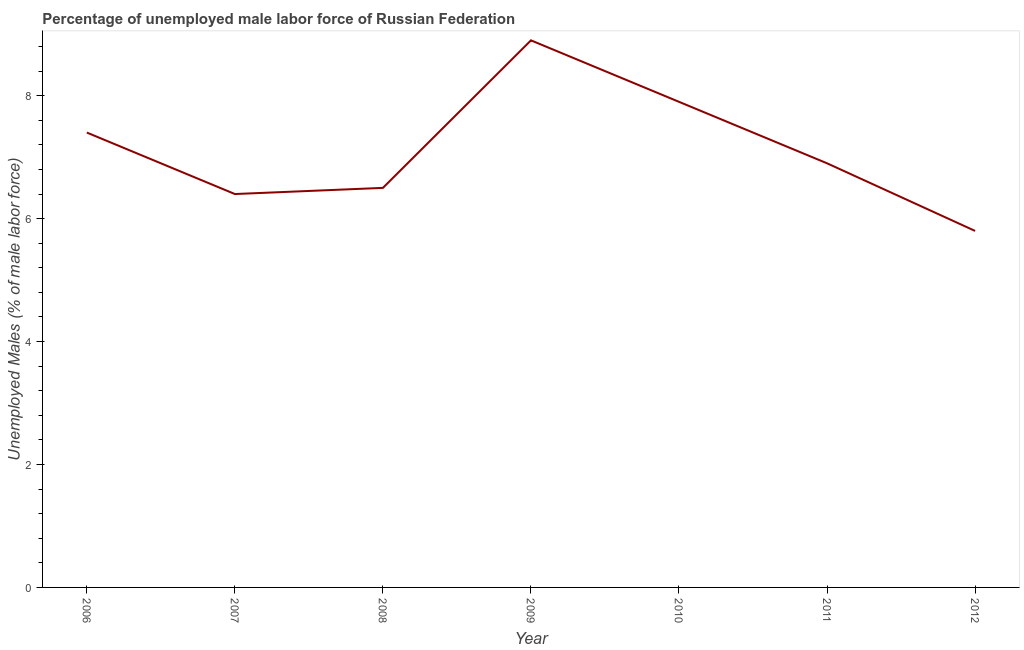What is the total unemployed male labour force in 2010?
Your answer should be compact. 7.9. Across all years, what is the maximum total unemployed male labour force?
Give a very brief answer. 8.9. Across all years, what is the minimum total unemployed male labour force?
Give a very brief answer. 5.8. In which year was the total unemployed male labour force maximum?
Ensure brevity in your answer.  2009. In which year was the total unemployed male labour force minimum?
Offer a terse response. 2012. What is the sum of the total unemployed male labour force?
Provide a succinct answer. 49.8. What is the difference between the total unemployed male labour force in 2007 and 2012?
Your answer should be very brief. 0.6. What is the average total unemployed male labour force per year?
Provide a succinct answer. 7.11. What is the median total unemployed male labour force?
Make the answer very short. 6.9. In how many years, is the total unemployed male labour force greater than 6.8 %?
Provide a succinct answer. 4. Do a majority of the years between 2010 and 2012 (inclusive) have total unemployed male labour force greater than 2.4 %?
Your answer should be very brief. Yes. What is the ratio of the total unemployed male labour force in 2007 to that in 2008?
Provide a succinct answer. 0.98. Is the total unemployed male labour force in 2008 less than that in 2010?
Your answer should be very brief. Yes. What is the difference between the highest and the second highest total unemployed male labour force?
Give a very brief answer. 1. Is the sum of the total unemployed male labour force in 2006 and 2011 greater than the maximum total unemployed male labour force across all years?
Ensure brevity in your answer.  Yes. What is the difference between the highest and the lowest total unemployed male labour force?
Your answer should be very brief. 3.1. How many lines are there?
Your answer should be very brief. 1. How many years are there in the graph?
Offer a terse response. 7. What is the difference between two consecutive major ticks on the Y-axis?
Offer a terse response. 2. Does the graph contain grids?
Make the answer very short. No. What is the title of the graph?
Give a very brief answer. Percentage of unemployed male labor force of Russian Federation. What is the label or title of the X-axis?
Keep it short and to the point. Year. What is the label or title of the Y-axis?
Offer a terse response. Unemployed Males (% of male labor force). What is the Unemployed Males (% of male labor force) of 2006?
Give a very brief answer. 7.4. What is the Unemployed Males (% of male labor force) of 2007?
Offer a very short reply. 6.4. What is the Unemployed Males (% of male labor force) of 2009?
Make the answer very short. 8.9. What is the Unemployed Males (% of male labor force) in 2010?
Keep it short and to the point. 7.9. What is the Unemployed Males (% of male labor force) of 2011?
Offer a terse response. 6.9. What is the Unemployed Males (% of male labor force) in 2012?
Make the answer very short. 5.8. What is the difference between the Unemployed Males (% of male labor force) in 2006 and 2008?
Your response must be concise. 0.9. What is the difference between the Unemployed Males (% of male labor force) in 2007 and 2008?
Your answer should be very brief. -0.1. What is the difference between the Unemployed Males (% of male labor force) in 2007 and 2009?
Ensure brevity in your answer.  -2.5. What is the difference between the Unemployed Males (% of male labor force) in 2007 and 2011?
Offer a terse response. -0.5. What is the difference between the Unemployed Males (% of male labor force) in 2008 and 2009?
Provide a short and direct response. -2.4. What is the difference between the Unemployed Males (% of male labor force) in 2008 and 2010?
Provide a succinct answer. -1.4. What is the difference between the Unemployed Males (% of male labor force) in 2008 and 2011?
Provide a succinct answer. -0.4. What is the difference between the Unemployed Males (% of male labor force) in 2008 and 2012?
Your answer should be compact. 0.7. What is the ratio of the Unemployed Males (% of male labor force) in 2006 to that in 2007?
Make the answer very short. 1.16. What is the ratio of the Unemployed Males (% of male labor force) in 2006 to that in 2008?
Your answer should be very brief. 1.14. What is the ratio of the Unemployed Males (% of male labor force) in 2006 to that in 2009?
Offer a very short reply. 0.83. What is the ratio of the Unemployed Males (% of male labor force) in 2006 to that in 2010?
Give a very brief answer. 0.94. What is the ratio of the Unemployed Males (% of male labor force) in 2006 to that in 2011?
Provide a short and direct response. 1.07. What is the ratio of the Unemployed Males (% of male labor force) in 2006 to that in 2012?
Offer a terse response. 1.28. What is the ratio of the Unemployed Males (% of male labor force) in 2007 to that in 2008?
Your answer should be compact. 0.98. What is the ratio of the Unemployed Males (% of male labor force) in 2007 to that in 2009?
Offer a terse response. 0.72. What is the ratio of the Unemployed Males (% of male labor force) in 2007 to that in 2010?
Keep it short and to the point. 0.81. What is the ratio of the Unemployed Males (% of male labor force) in 2007 to that in 2011?
Provide a succinct answer. 0.93. What is the ratio of the Unemployed Males (% of male labor force) in 2007 to that in 2012?
Your answer should be very brief. 1.1. What is the ratio of the Unemployed Males (% of male labor force) in 2008 to that in 2009?
Your answer should be compact. 0.73. What is the ratio of the Unemployed Males (% of male labor force) in 2008 to that in 2010?
Your response must be concise. 0.82. What is the ratio of the Unemployed Males (% of male labor force) in 2008 to that in 2011?
Make the answer very short. 0.94. What is the ratio of the Unemployed Males (% of male labor force) in 2008 to that in 2012?
Make the answer very short. 1.12. What is the ratio of the Unemployed Males (% of male labor force) in 2009 to that in 2010?
Your answer should be compact. 1.13. What is the ratio of the Unemployed Males (% of male labor force) in 2009 to that in 2011?
Make the answer very short. 1.29. What is the ratio of the Unemployed Males (% of male labor force) in 2009 to that in 2012?
Your response must be concise. 1.53. What is the ratio of the Unemployed Males (% of male labor force) in 2010 to that in 2011?
Make the answer very short. 1.15. What is the ratio of the Unemployed Males (% of male labor force) in 2010 to that in 2012?
Offer a very short reply. 1.36. What is the ratio of the Unemployed Males (% of male labor force) in 2011 to that in 2012?
Give a very brief answer. 1.19. 